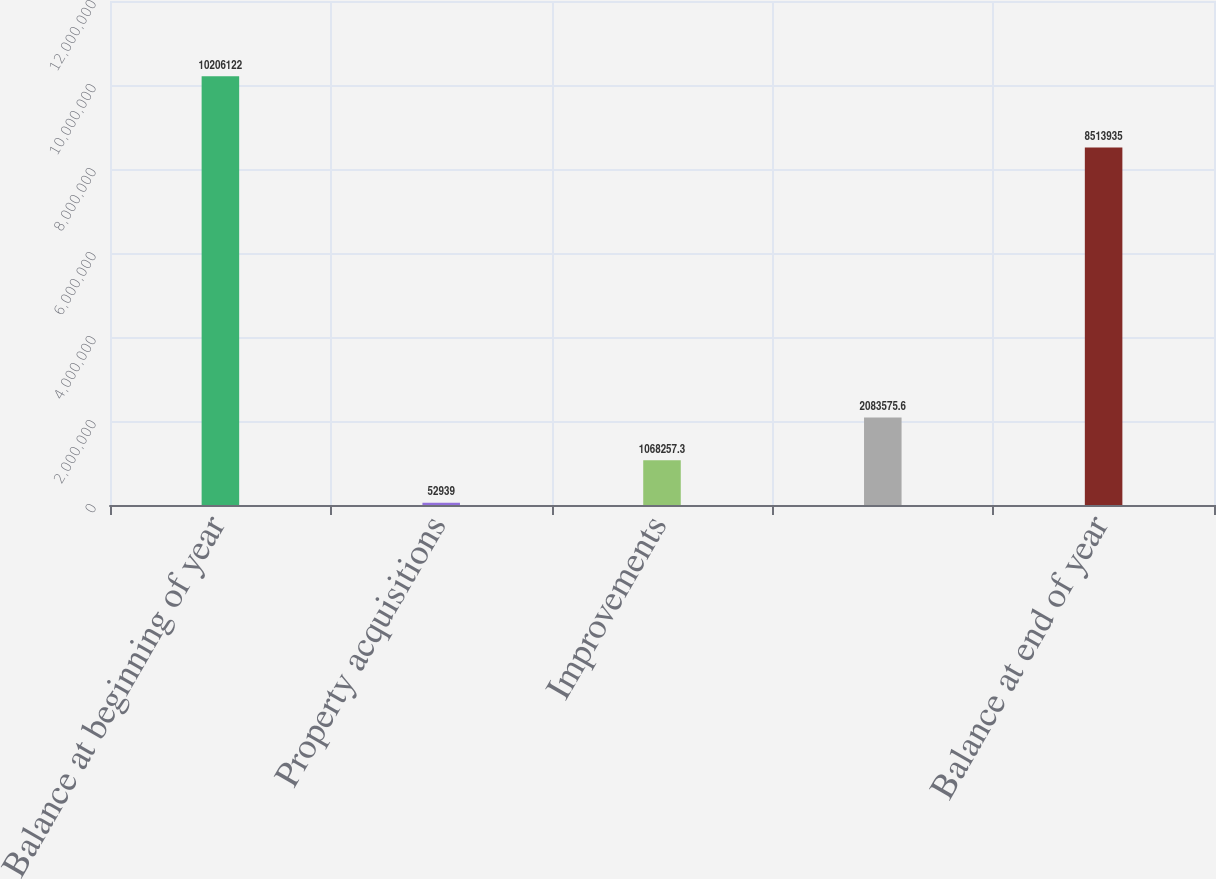Convert chart to OTSL. <chart><loc_0><loc_0><loc_500><loc_500><bar_chart><fcel>Balance at beginning of year<fcel>Property acquisitions<fcel>Improvements<fcel>Unnamed: 3<fcel>Balance at end of year<nl><fcel>1.02061e+07<fcel>52939<fcel>1.06826e+06<fcel>2.08358e+06<fcel>8.51394e+06<nl></chart> 